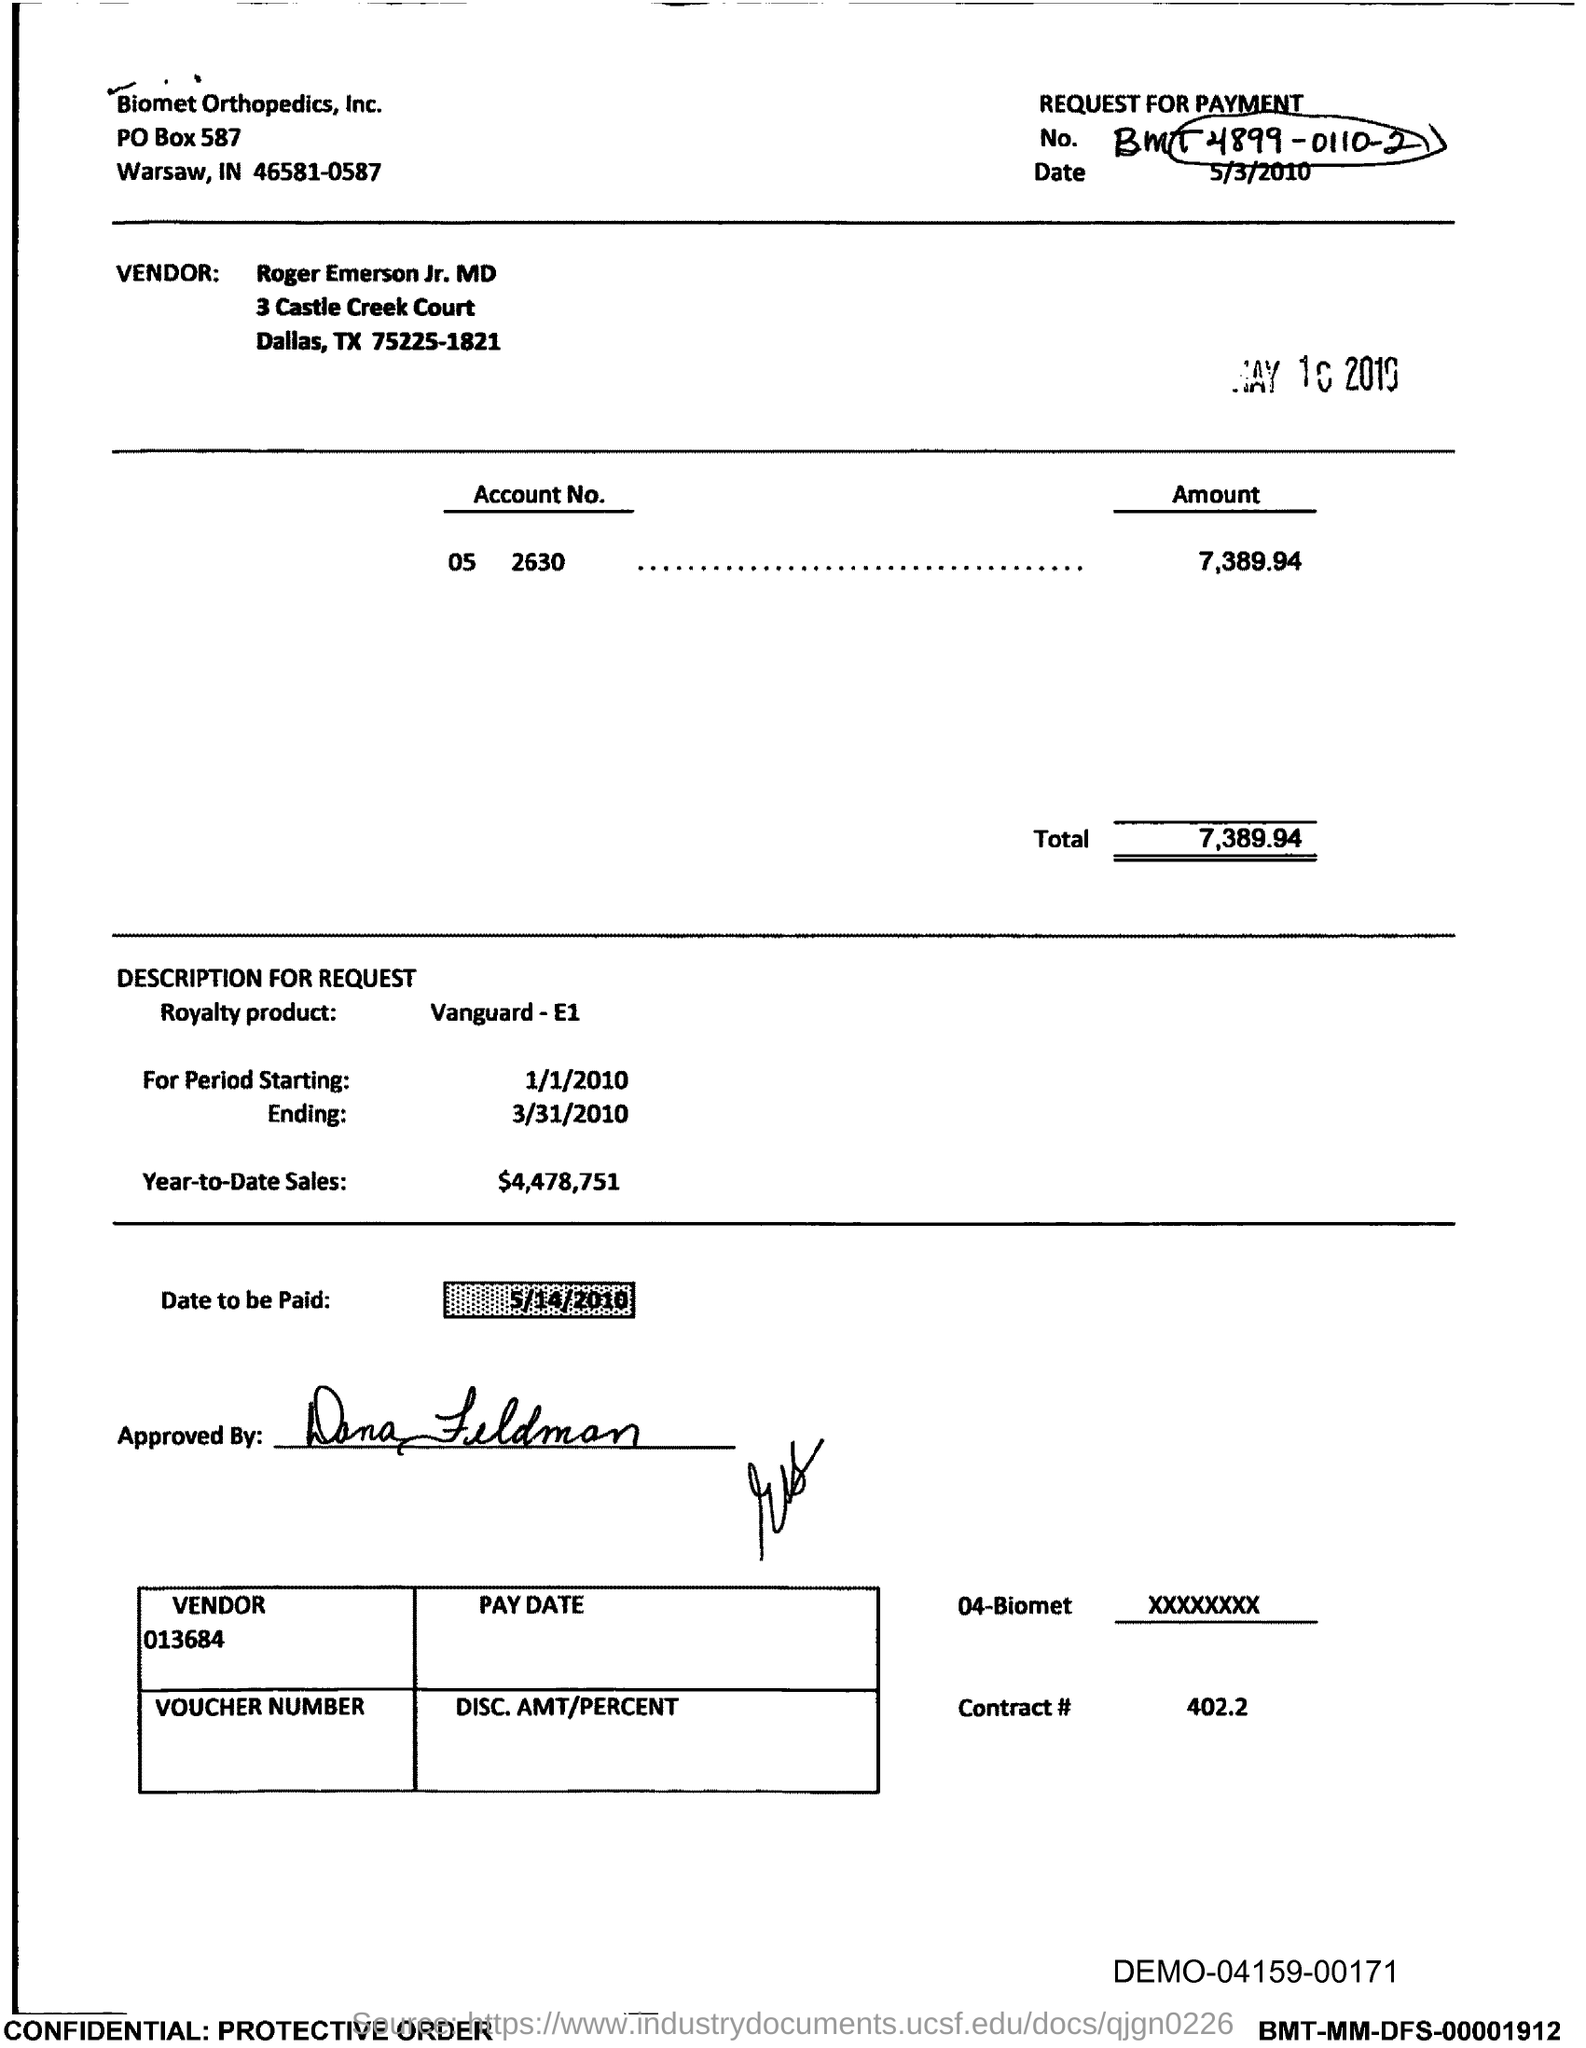What is the PO Box Number mentioned in the document?
Offer a very short reply. 587. What is the Total?
Your response must be concise. 7,389.94. What is the Contract # Number?
Make the answer very short. 402.2. 